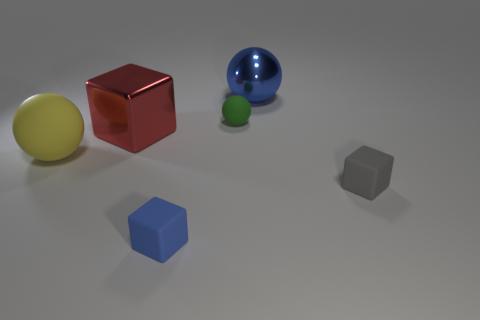What is the material of the blue object that is behind the red cube? The blue object appears to have a smooth and reflective surface, which is characteristic of materials like glass or polished metal. Without more specific information, it's difficult to determine the exact type of material, but it is likely to be one of these given its visual properties. 